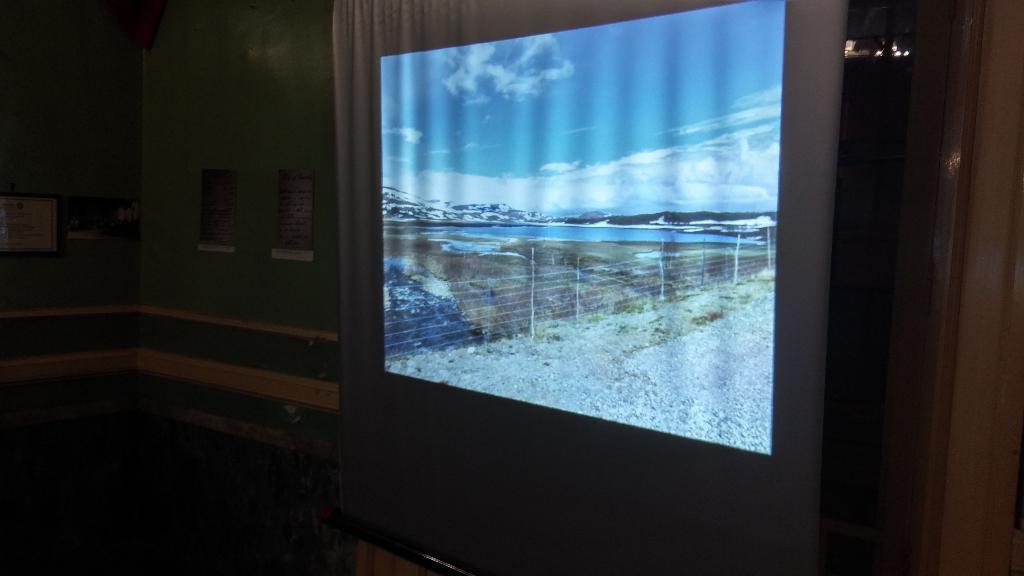Can you describe this image briefly? In this image we can see a screen and a landscape image, which contains fences, water body and mountains are projected on the screen, behind it there is a wall which contains posters on it. 